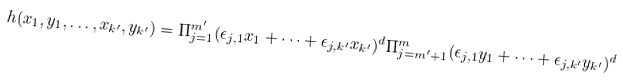Convert formula to latex. <formula><loc_0><loc_0><loc_500><loc_500>h ( x _ { 1 } , y _ { 1 } , \dots , x _ { k ^ { \prime } } , y _ { k ^ { \prime } } ) = \Pi _ { j = 1 } ^ { m ^ { \prime } } ( \epsilon _ { j , 1 } x _ { 1 } + \cdots + \epsilon _ { j , k ^ { \prime } } x _ { k ^ { \prime } } ) ^ { d } \Pi _ { j = m ^ { \prime } + 1 } ^ { m } ( \epsilon _ { j , 1 } y _ { 1 } + \cdots + \epsilon _ { j , k ^ { \prime } } y _ { k ^ { \prime } } ) ^ { d }</formula> 